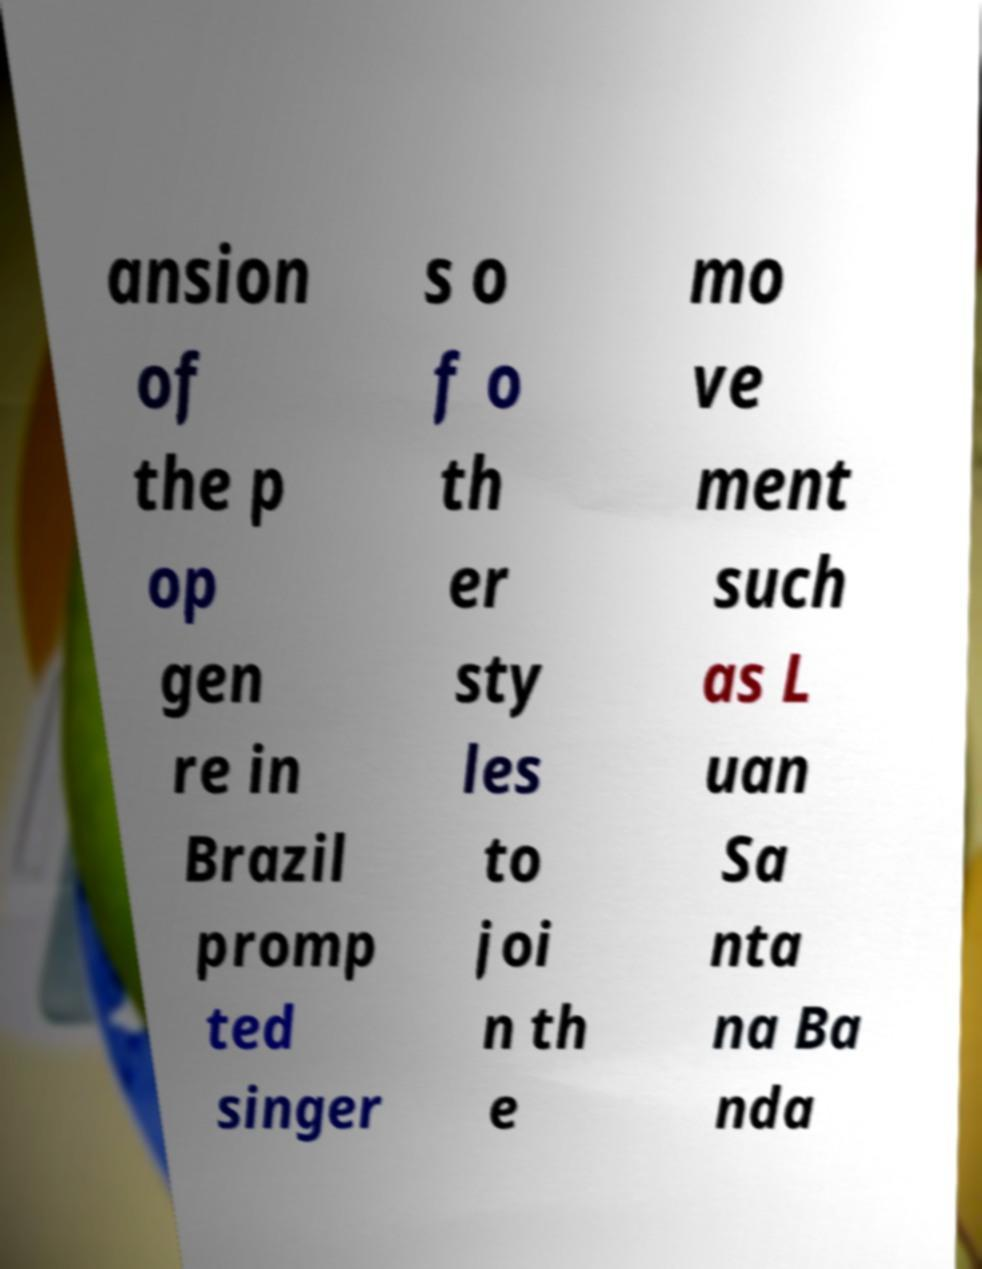Can you accurately transcribe the text from the provided image for me? ansion of the p op gen re in Brazil promp ted singer s o f o th er sty les to joi n th e mo ve ment such as L uan Sa nta na Ba nda 